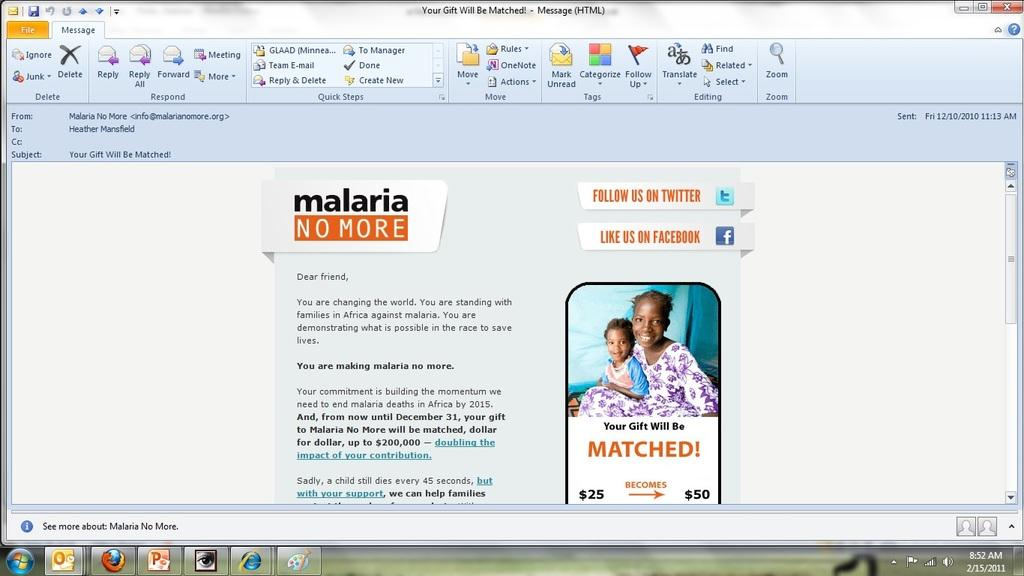<image>
Offer a succinct explanation of the picture presented. A computer display with an ad for Malaria shows it is 8:52 AM 